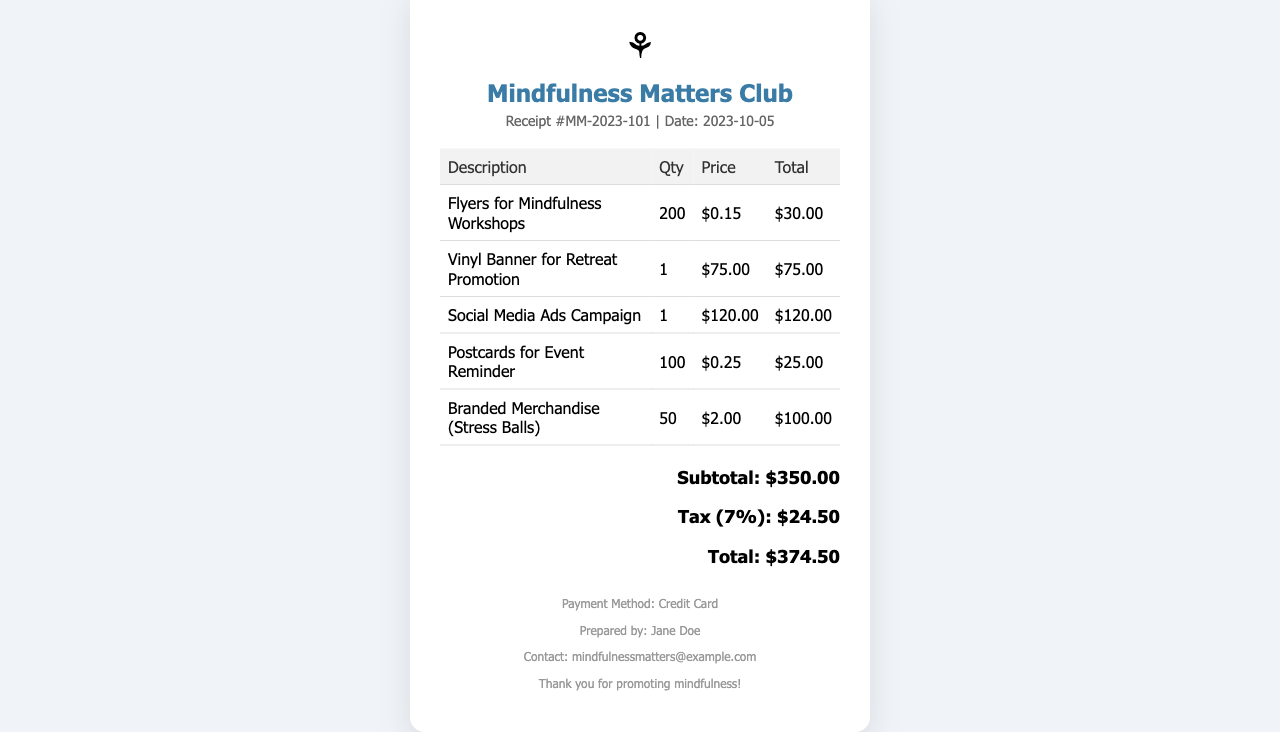What is the date on the receipt? The date is listed prominently in the receipt, indicating when the transaction took place.
Answer: 2023-10-05 What is the total amount due? The total amount due is provided in the summary section at the bottom of the receipt.
Answer: $374.50 How much was spent on flyers? The cost for flyers is detailed in the itemized table, showing the specific charge for that item.
Answer: $30.00 What is the quantity of stress balls ordered? The quantity is specified in the table alongside the description of the branded merchandise item.
Answer: 50 What is the tax rate applied in the document? The tax rate is mentioned just above the total amount, providing clarity on the calculation of the tax.
Answer: 7% What is the subtotal amount before tax? The subtotal is noted clearly in the summary section before the tax amount is added.
Answer: $350.00 Who prepared the receipt? The name of the individual who prepared the receipt is included in the footer section for reference.
Answer: Jane Doe What type of payment method was used? The payment method is indicated at the bottom of the receipt, providing information about how the transaction was processed.
Answer: Credit Card What is the email address for contact? The contact information is also listed in the footer section of the receipt for follow-up or inquiries.
Answer: mindfulnessmatters@example.com 